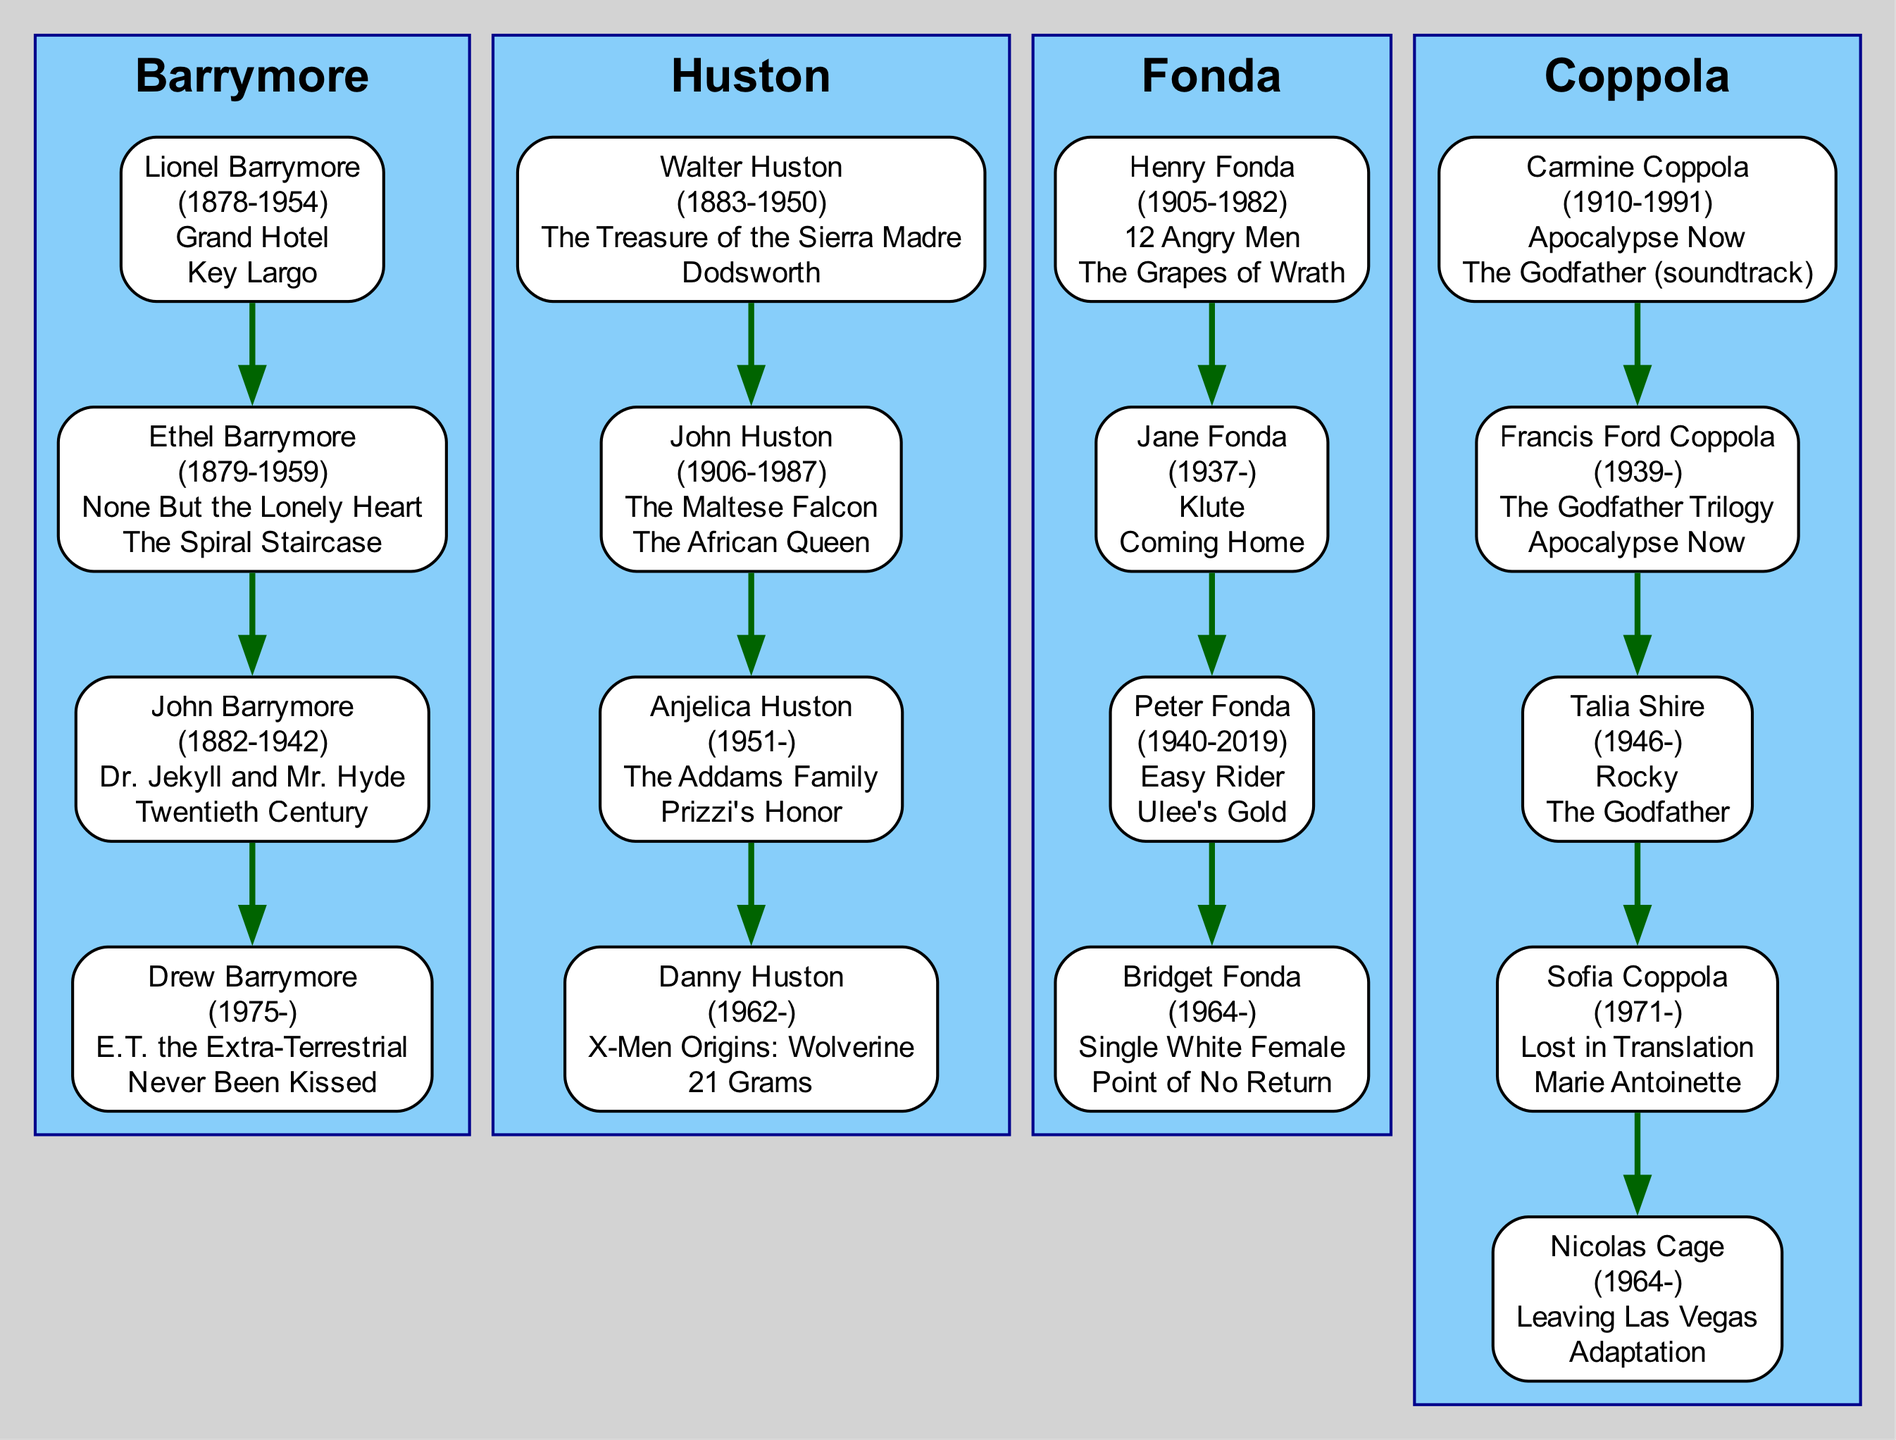What is the birth year of Drew Barrymore? From the diagram, Drew Barrymore is listed as a family member under the Barrymore dynasty. Her birth year is explicitly mentioned next to her name as 1975.
Answer: 1975 Which family has a member named Anjelica Huston? By looking at the diagram, Anjelica Huston is shown as a member of the Huston family. This is indicated by her position under the Huston cluster.
Answer: Huston How many contributions does Henry Fonda have listed? The diagram shows only the first two contributions of each family member, and for Henry Fonda, two contributions are presented: "12 Angry Men" and "The Grapes of Wrath". Thus, he has 2 contributions listed.
Answer: 2 Who is the earliest born member in the Barrymore family? Upon reviewing the Barrymore family members, Lionel Barrymore has the earliest birth year of 1878, which is indicated next to his name.
Answer: Lionel Barrymore Which member from the Coppola family is born in 1971? Looking at the Coppola family section of the diagram, Sofia Coppola is the member listed with the birth year of 1971 next to her name.
Answer: Sofia Coppola How many total acting families are represented in this diagram? The diagram contains 4 distinct family clusters, which are Barrymore, Huston, Fonda, and Coppola. Therefore, the total number of acting families is 4.
Answer: 4 What are the contributions of Peter Fonda? From the Fonda family section of the diagram, Peter Fonda's contributions are specifically listed as "Easy Rider" and "Ulee's Gold." This information is found beneath his name.
Answer: Easy Rider, Ulee's Gold Which generation includes both John Huston and Walter Huston? According to the timeline indicated by their birth years, Walter Huston (1883) is the father of John Huston (1906). This means both members belong to the same acting lineage across generations.
Answer: Huston family Name a movie that Drew Barrymore contributed to. The diagram shows that Drew Barrymore is credited with several contributions, including "E.T. the Extra-Terrestrial", which is one of the films listed next to her name.
Answer: E.T. the Extra-Terrestrial 